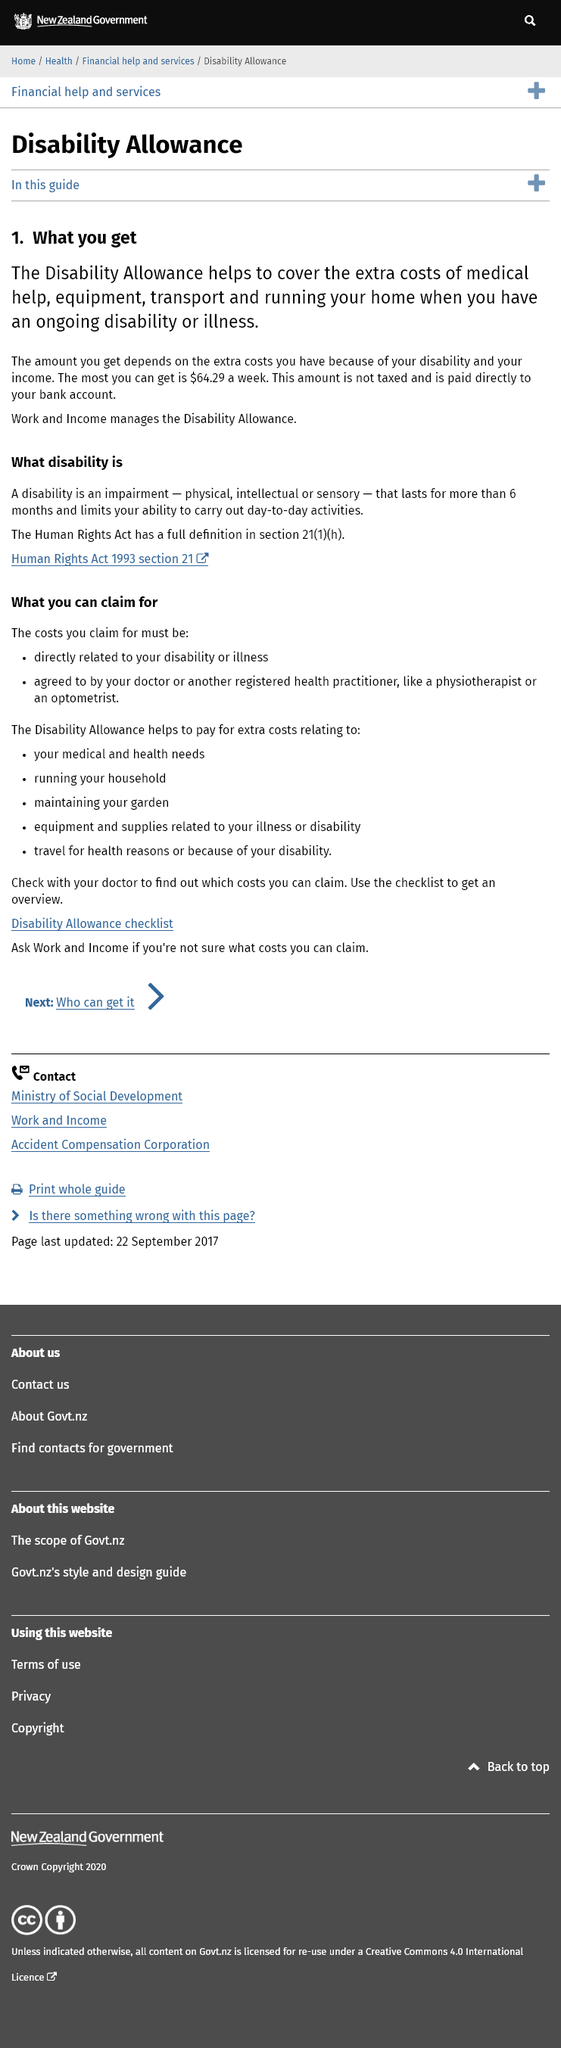Specify some key components in this picture. A disability is defined as an impairment that lasts for more than six months and limits an individual's ability to perform daily tasks and activities. Disability allowance covers the additional costs associated with medical assistance, equipment, transportation, and the operation of one's home for individuals who have a disability or illness. The maximum amount of disability allowance that can be expected to receive is €64.29 weekly. 